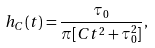Convert formula to latex. <formula><loc_0><loc_0><loc_500><loc_500>h _ { C } ( t ) = \frac { \tau _ { 0 } } { \pi [ C t ^ { 2 } + \tau _ { 0 } ^ { 2 } ] } ,</formula> 